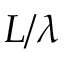Convert formula to latex. <formula><loc_0><loc_0><loc_500><loc_500>L / \lambda</formula> 